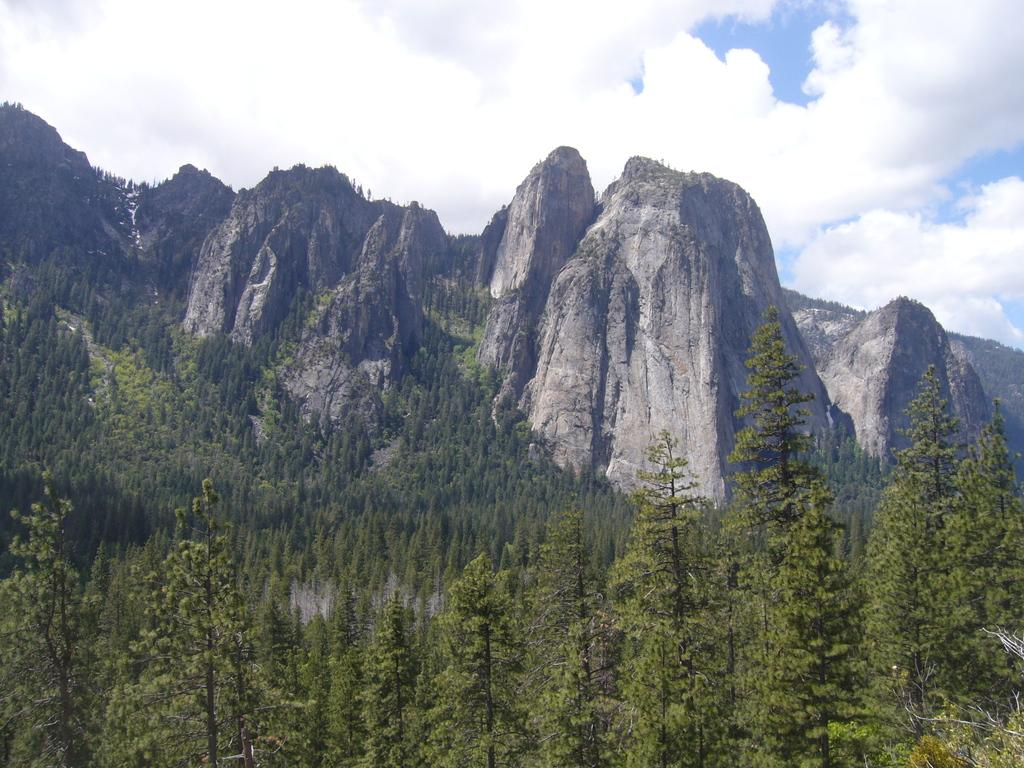What type of vegetation is present in the image? There are many tall trees in the image. What can be seen in the background behind the trees? There are hills visible behind the trees. What type of notebook is being used by the person in the image? There is no person or notebook present in the image; it only features tall trees and hills in the background. 